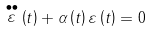<formula> <loc_0><loc_0><loc_500><loc_500>\stackrel { \bullet \bullet } { \varepsilon } \left ( t \right ) + \alpha \left ( t \right ) \varepsilon \left ( t \right ) = 0</formula> 